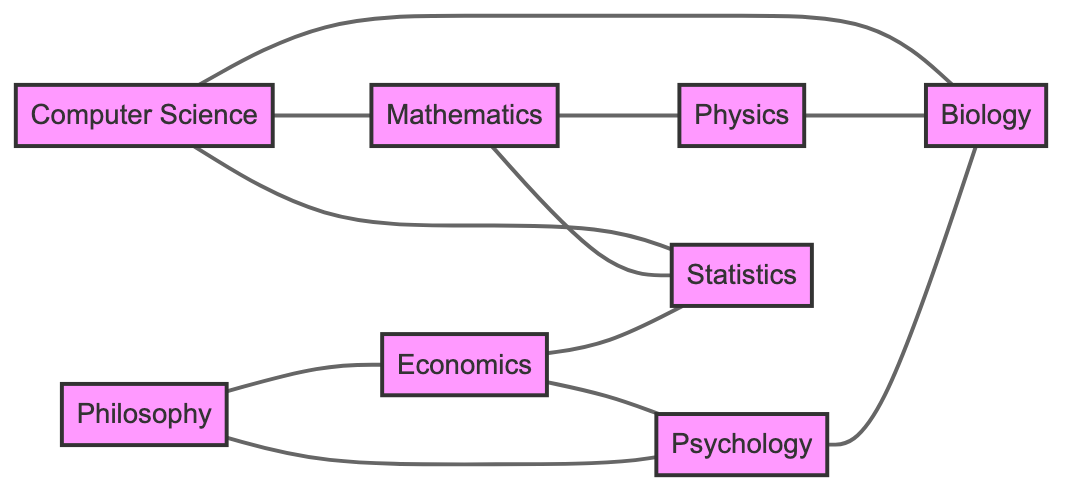What is the total number of subjects in the curriculum? The diagram shows a total of eight distinct fields: Computer Science, Mathematics, Physics, Economics, Philosophy, Psychology, Biology, and Statistics. Counting these gives us a total of eight subjects.
Answer: eight Which two subjects are directly connected to Philosophy? In the diagram, Philosophy is connected to two subjects: Economics and Psychology. To find this, I can look at the edges connected to the Philosophy node.
Answer: Economics, Psychology How many subjects are interconnected with Statistics? The Statistics subject has direct connections with three other subjects: Computer Science, Mathematics, and Economics. By inspecting the adjacent nodes connected directly to Statistics, we can count each distinct one.
Answer: three Is there a subject that connects Physics and Biology? Yes, there is a direct connection between Physics and Biology. They share an edge in the diagram, indicating that they are interrelated in the curriculum.
Answer: yes Which subject is connected to the highest number of subjects? By analyzing the connections, Computer Science connects to four subjects: Mathematics, Statistics, Biology, and Economics. Thus, it has the highest degree of connectivity.
Answer: Computer Science Are Psychology and Biology directly related in the diagram? Yes, they are directly related as there is an edge connecting them in the diagram. Simply check for a direct line drawn between the two nodes to confirm this relationship.
Answer: yes How many connections does Mathematics have in total? Mathematics has three connections: to Computer Science, Physics, and Statistics. Counting each edge extending from the Mathematics node confirms this total.
Answer: three What is the relationship between Economics and Psychology? The relationship is mutual; Economics is directly connected to Psychology, meaning they share an edge. This can be verified by examining the connections in the diagram.
Answer: directly connected Which subject serves as a bridge between Psychology and Biology? In this graph, Philosophy acts as a bridge because it connects both Psychology and Economics, establishing an indirect connection to Biology via Psychology. I trace the connections from Psychology to Economics and then to Biology to identify this.
Answer: Philosophy 